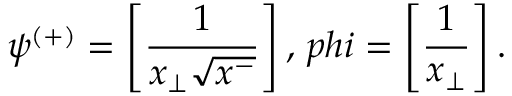<formula> <loc_0><loc_0><loc_500><loc_500>\psi ^ { ( + ) } = \left [ \frac { 1 } { x _ { \perp } \sqrt { x ^ { - } } } \right ] , \, p h i = \left [ \frac { 1 } { x _ { \perp } } \right ] .</formula> 